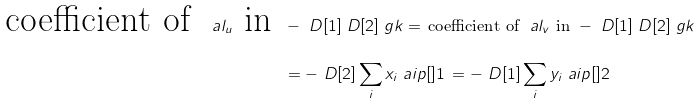<formula> <loc_0><loc_0><loc_500><loc_500>\text {coefficient of } \ a l _ { u } \text { in } & - \ D [ 1 ] \ D [ 2 ] \ g k = \, \text {coefficient of } \ a l _ { v } \text { in } - \ D [ 1 ] \ D [ 2 ] \ g k \\ & = - \ D [ 2 ] \sum _ { i } x _ { i } \ a i p [ ] { 1 } \, = - \ D [ 1 ] \sum _ { i } y _ { i } \ a i p [ ] { 2 }</formula> 